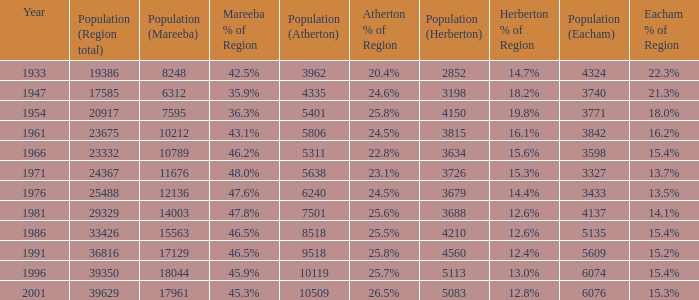What was the minimum population number for mareeba? 6312.0. 